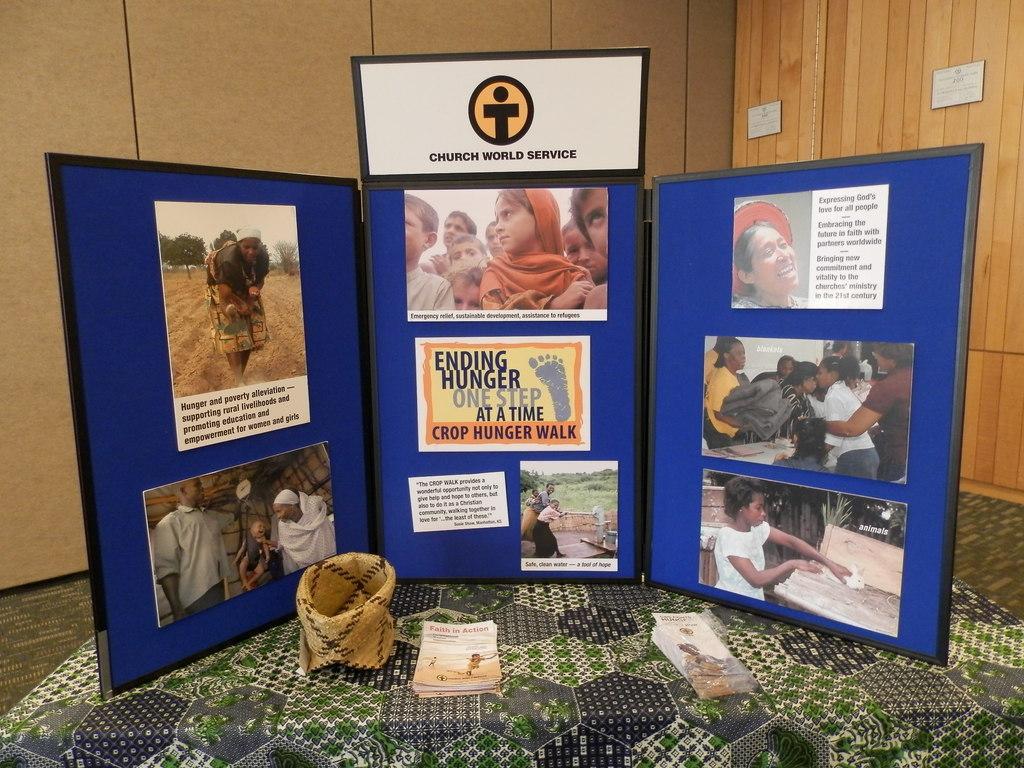In one or two sentences, can you explain what this image depicts? In this picture there is a blue color frame with photos. Behind there is a wooden panel wall. 